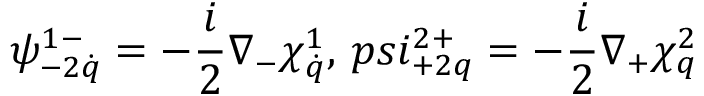Convert formula to latex. <formula><loc_0><loc_0><loc_500><loc_500>\psi _ { - 2 \dot { q } } ^ { 1 - } = - \frac { i } { 2 } \nabla _ { - } \chi _ { \dot { q } } ^ { 1 } , \, p s i _ { + 2 q } ^ { 2 + } = - \frac { i } { 2 } \nabla _ { + } \chi _ { q } ^ { 2 }</formula> 